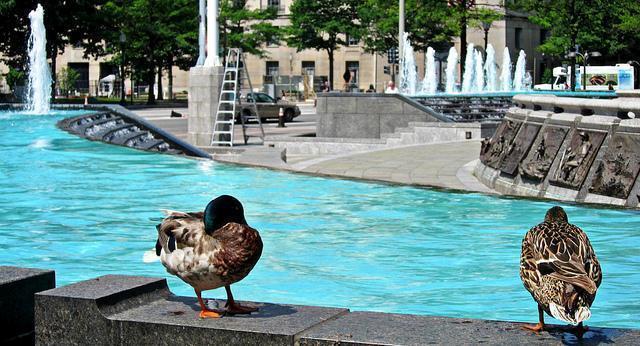Why are they here?
Answer the question by selecting the correct answer among the 4 following choices and explain your choice with a short sentence. The answer should be formatted with the following format: `Answer: choice
Rationale: rationale.`
Options: Like water, are lost, are resting, are stuck. Answer: like water.
Rationale: Ducks love to be in water. 